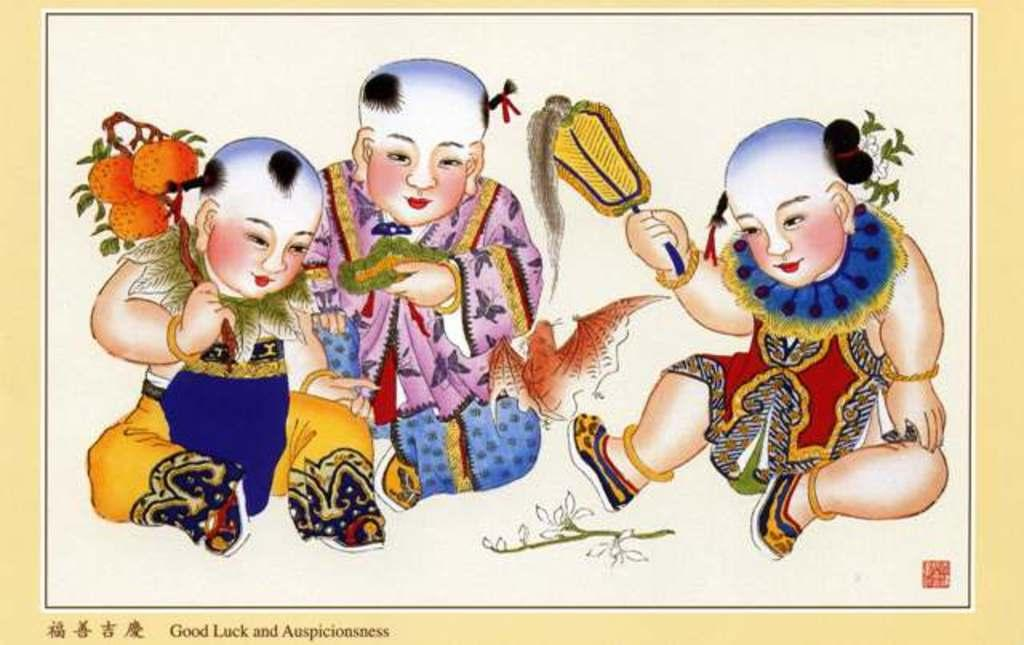What is the main subject of the paintings in the image? The main subjects of the paintings in the image are three persons, fruits, and plants. What other objects are depicted in the paintings? There are other objects depicted in the paintings, but the provided facts do not specify their nature. How are the paintings displayed in the image? The image appears to be a photo frame, which suggests that the paintings are displayed within it. How many cats are sitting on the pan in the image? There are no cats or pans present in the image. Is there a lock on the frame of the paintings in the image? The provided facts do not mention a lock on the frame of the paintings in the image. 